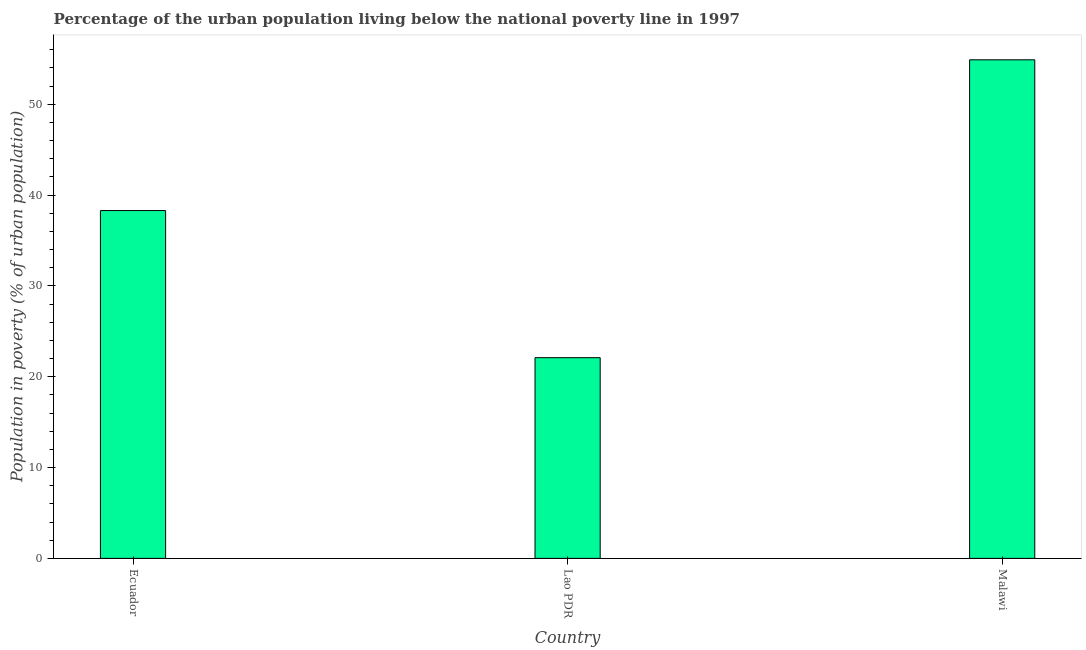What is the title of the graph?
Make the answer very short. Percentage of the urban population living below the national poverty line in 1997. What is the label or title of the X-axis?
Keep it short and to the point. Country. What is the label or title of the Y-axis?
Make the answer very short. Population in poverty (% of urban population). What is the percentage of urban population living below poverty line in Lao PDR?
Offer a terse response. 22.1. Across all countries, what is the maximum percentage of urban population living below poverty line?
Provide a succinct answer. 54.9. Across all countries, what is the minimum percentage of urban population living below poverty line?
Provide a succinct answer. 22.1. In which country was the percentage of urban population living below poverty line maximum?
Your answer should be very brief. Malawi. In which country was the percentage of urban population living below poverty line minimum?
Keep it short and to the point. Lao PDR. What is the sum of the percentage of urban population living below poverty line?
Offer a terse response. 115.3. What is the difference between the percentage of urban population living below poverty line in Lao PDR and Malawi?
Provide a succinct answer. -32.8. What is the average percentage of urban population living below poverty line per country?
Your response must be concise. 38.43. What is the median percentage of urban population living below poverty line?
Your answer should be very brief. 38.3. What is the ratio of the percentage of urban population living below poverty line in Ecuador to that in Malawi?
Keep it short and to the point. 0.7. Is the percentage of urban population living below poverty line in Lao PDR less than that in Malawi?
Provide a short and direct response. Yes. Is the difference between the percentage of urban population living below poverty line in Ecuador and Lao PDR greater than the difference between any two countries?
Offer a terse response. No. What is the difference between the highest and the second highest percentage of urban population living below poverty line?
Provide a succinct answer. 16.6. What is the difference between the highest and the lowest percentage of urban population living below poverty line?
Offer a very short reply. 32.8. Are all the bars in the graph horizontal?
Make the answer very short. No. How many countries are there in the graph?
Your response must be concise. 3. Are the values on the major ticks of Y-axis written in scientific E-notation?
Offer a very short reply. No. What is the Population in poverty (% of urban population) in Ecuador?
Ensure brevity in your answer.  38.3. What is the Population in poverty (% of urban population) of Lao PDR?
Provide a short and direct response. 22.1. What is the Population in poverty (% of urban population) of Malawi?
Make the answer very short. 54.9. What is the difference between the Population in poverty (% of urban population) in Ecuador and Malawi?
Offer a very short reply. -16.6. What is the difference between the Population in poverty (% of urban population) in Lao PDR and Malawi?
Give a very brief answer. -32.8. What is the ratio of the Population in poverty (% of urban population) in Ecuador to that in Lao PDR?
Your answer should be very brief. 1.73. What is the ratio of the Population in poverty (% of urban population) in Ecuador to that in Malawi?
Your answer should be compact. 0.7. What is the ratio of the Population in poverty (% of urban population) in Lao PDR to that in Malawi?
Provide a short and direct response. 0.4. 